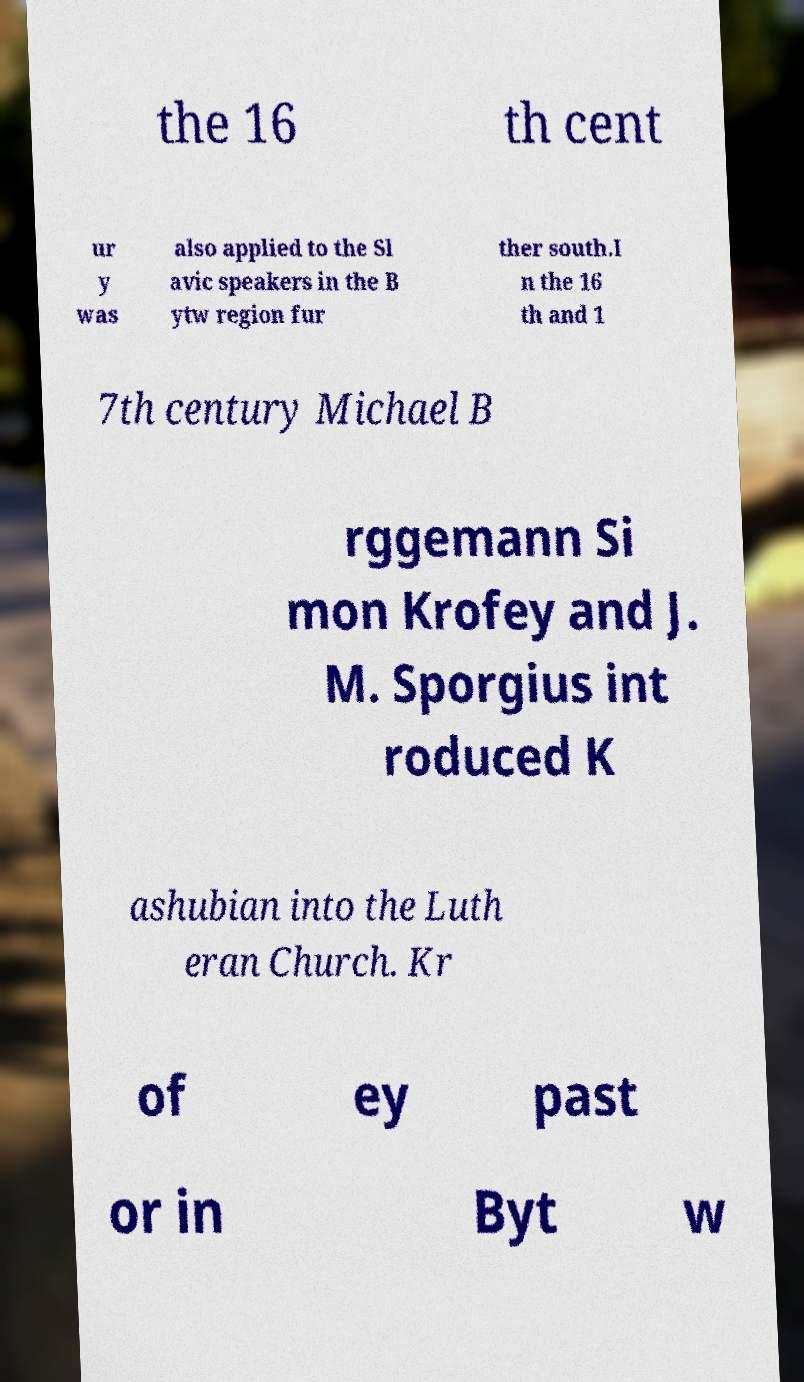For documentation purposes, I need the text within this image transcribed. Could you provide that? the 16 th cent ur y was also applied to the Sl avic speakers in the B ytw region fur ther south.I n the 16 th and 1 7th century Michael B rggemann Si mon Krofey and J. M. Sporgius int roduced K ashubian into the Luth eran Church. Kr of ey past or in Byt w 